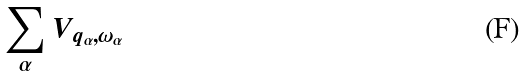<formula> <loc_0><loc_0><loc_500><loc_500>\sum _ { \alpha } V _ { q _ { \alpha } , \omega _ { \alpha } }</formula> 